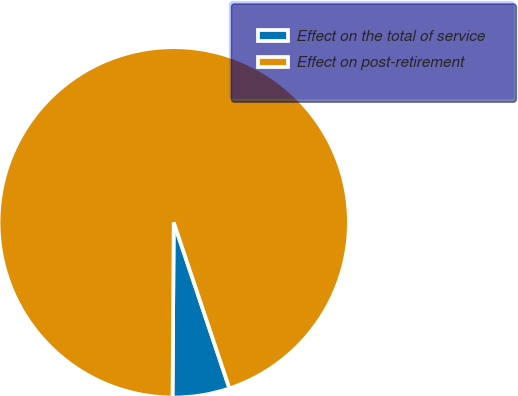<chart> <loc_0><loc_0><loc_500><loc_500><pie_chart><fcel>Effect on the total of service<fcel>Effect on post-retirement<nl><fcel>5.26%<fcel>94.74%<nl></chart> 